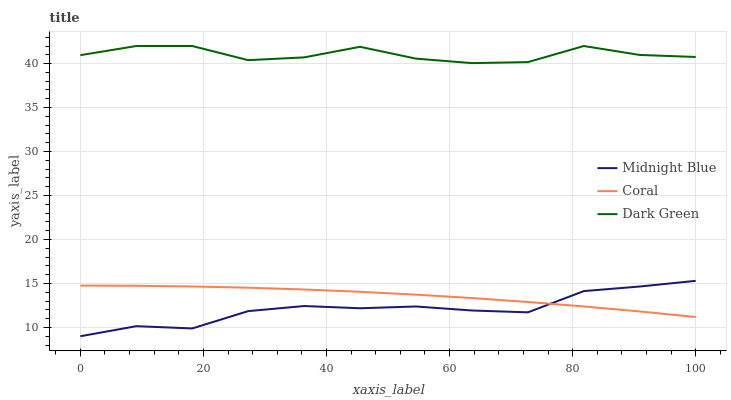Does Midnight Blue have the minimum area under the curve?
Answer yes or no. Yes. Does Dark Green have the maximum area under the curve?
Answer yes or no. Yes. Does Dark Green have the minimum area under the curve?
Answer yes or no. No. Does Midnight Blue have the maximum area under the curve?
Answer yes or no. No. Is Coral the smoothest?
Answer yes or no. Yes. Is Dark Green the roughest?
Answer yes or no. Yes. Is Midnight Blue the smoothest?
Answer yes or no. No. Is Midnight Blue the roughest?
Answer yes or no. No. Does Midnight Blue have the lowest value?
Answer yes or no. Yes. Does Dark Green have the lowest value?
Answer yes or no. No. Does Dark Green have the highest value?
Answer yes or no. Yes. Does Midnight Blue have the highest value?
Answer yes or no. No. Is Coral less than Dark Green?
Answer yes or no. Yes. Is Dark Green greater than Coral?
Answer yes or no. Yes. Does Midnight Blue intersect Coral?
Answer yes or no. Yes. Is Midnight Blue less than Coral?
Answer yes or no. No. Is Midnight Blue greater than Coral?
Answer yes or no. No. Does Coral intersect Dark Green?
Answer yes or no. No. 